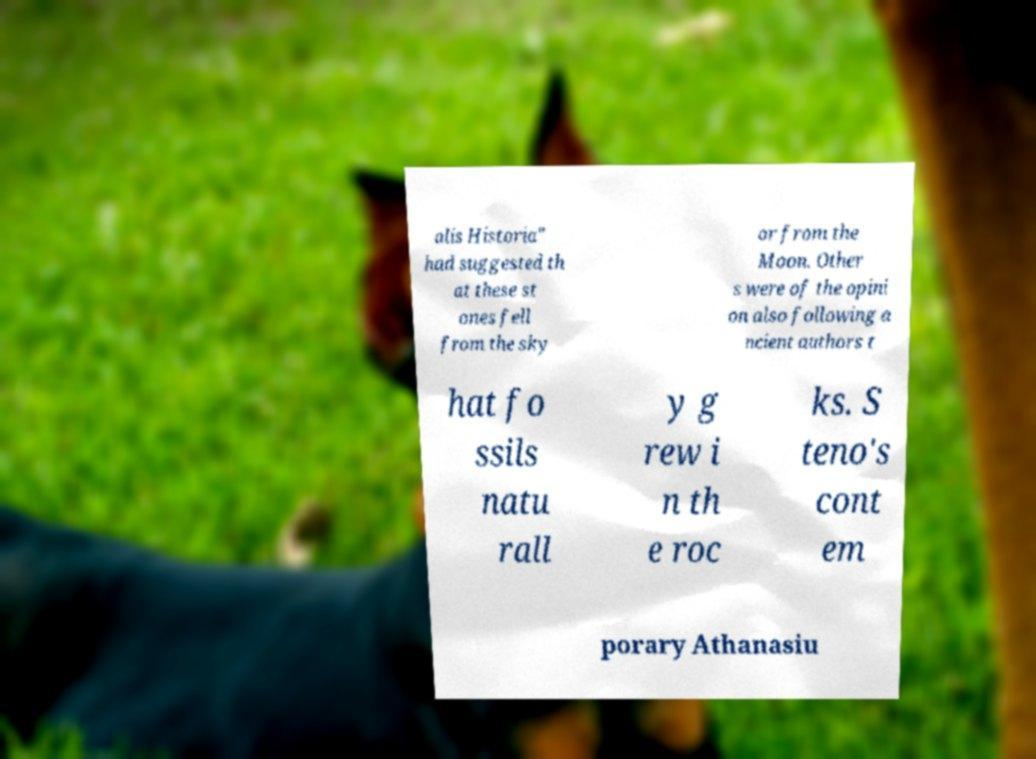Could you assist in decoding the text presented in this image and type it out clearly? alis Historia" had suggested th at these st ones fell from the sky or from the Moon. Other s were of the opini on also following a ncient authors t hat fo ssils natu rall y g rew i n th e roc ks. S teno's cont em porary Athanasiu 